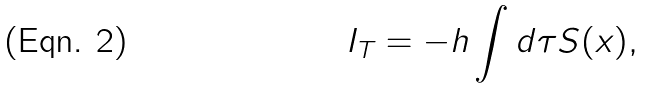<formula> <loc_0><loc_0><loc_500><loc_500>I _ { T } = - h \int d \tau S ( x ) ,</formula> 